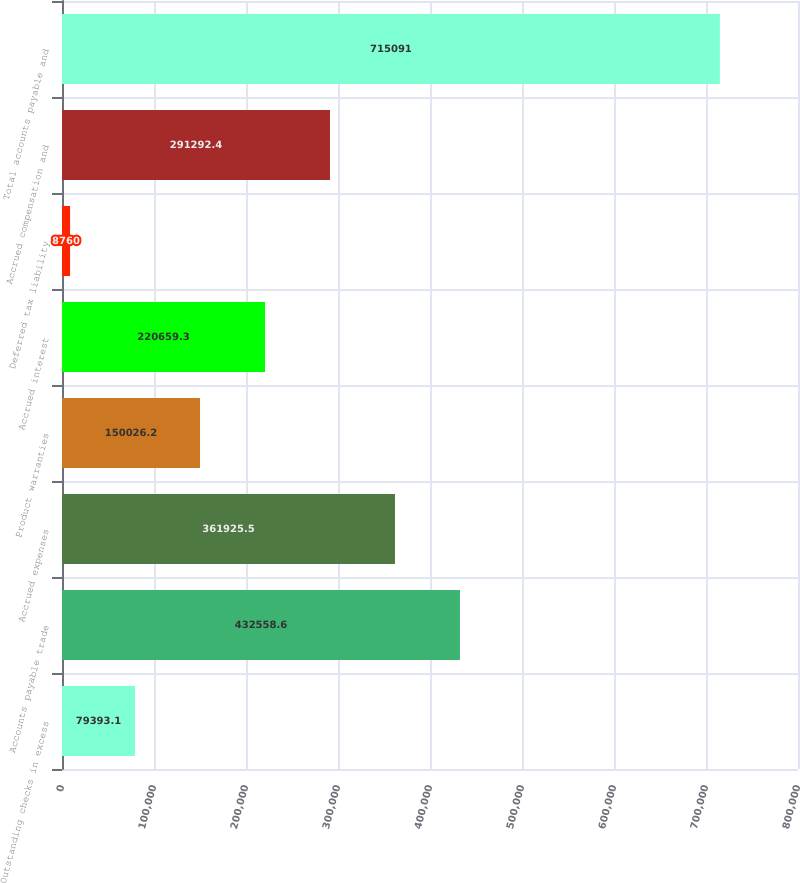<chart> <loc_0><loc_0><loc_500><loc_500><bar_chart><fcel>Outstanding checks in excess<fcel>Accounts payable trade<fcel>Accrued expenses<fcel>Product warranties<fcel>Accrued interest<fcel>Deferred tax liability<fcel>Accrued compensation and<fcel>Total accounts payable and<nl><fcel>79393.1<fcel>432559<fcel>361926<fcel>150026<fcel>220659<fcel>8760<fcel>291292<fcel>715091<nl></chart> 